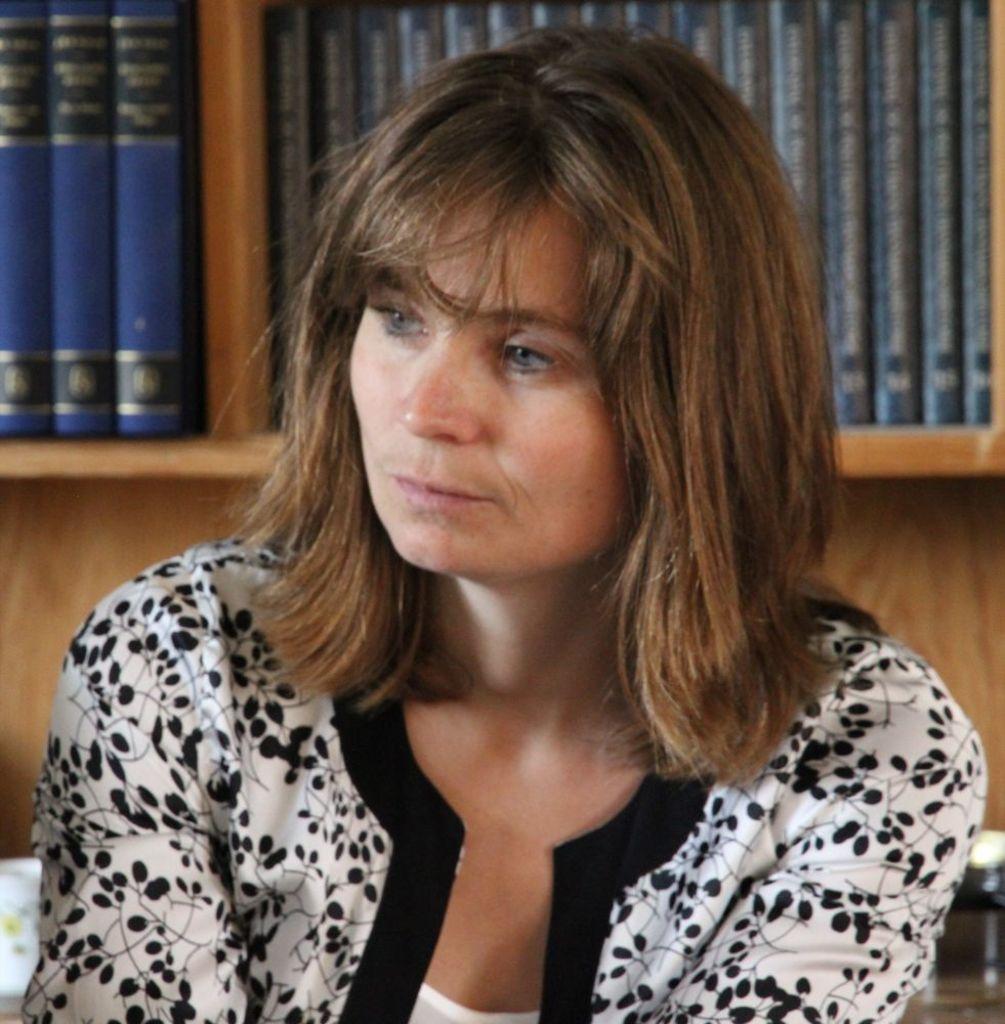Describe this image in one or two sentences. In this picture we can see a woman in the white and black dress and behind the women there are books on the rack. 